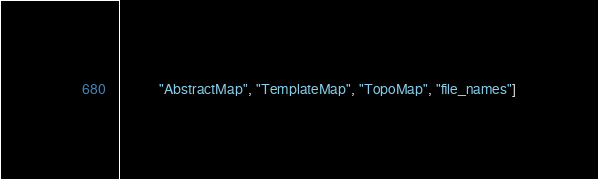Convert code to text. <code><loc_0><loc_0><loc_500><loc_500><_Python_>           "AbstractMap", "TemplateMap", "TopoMap", "file_names"]
</code> 